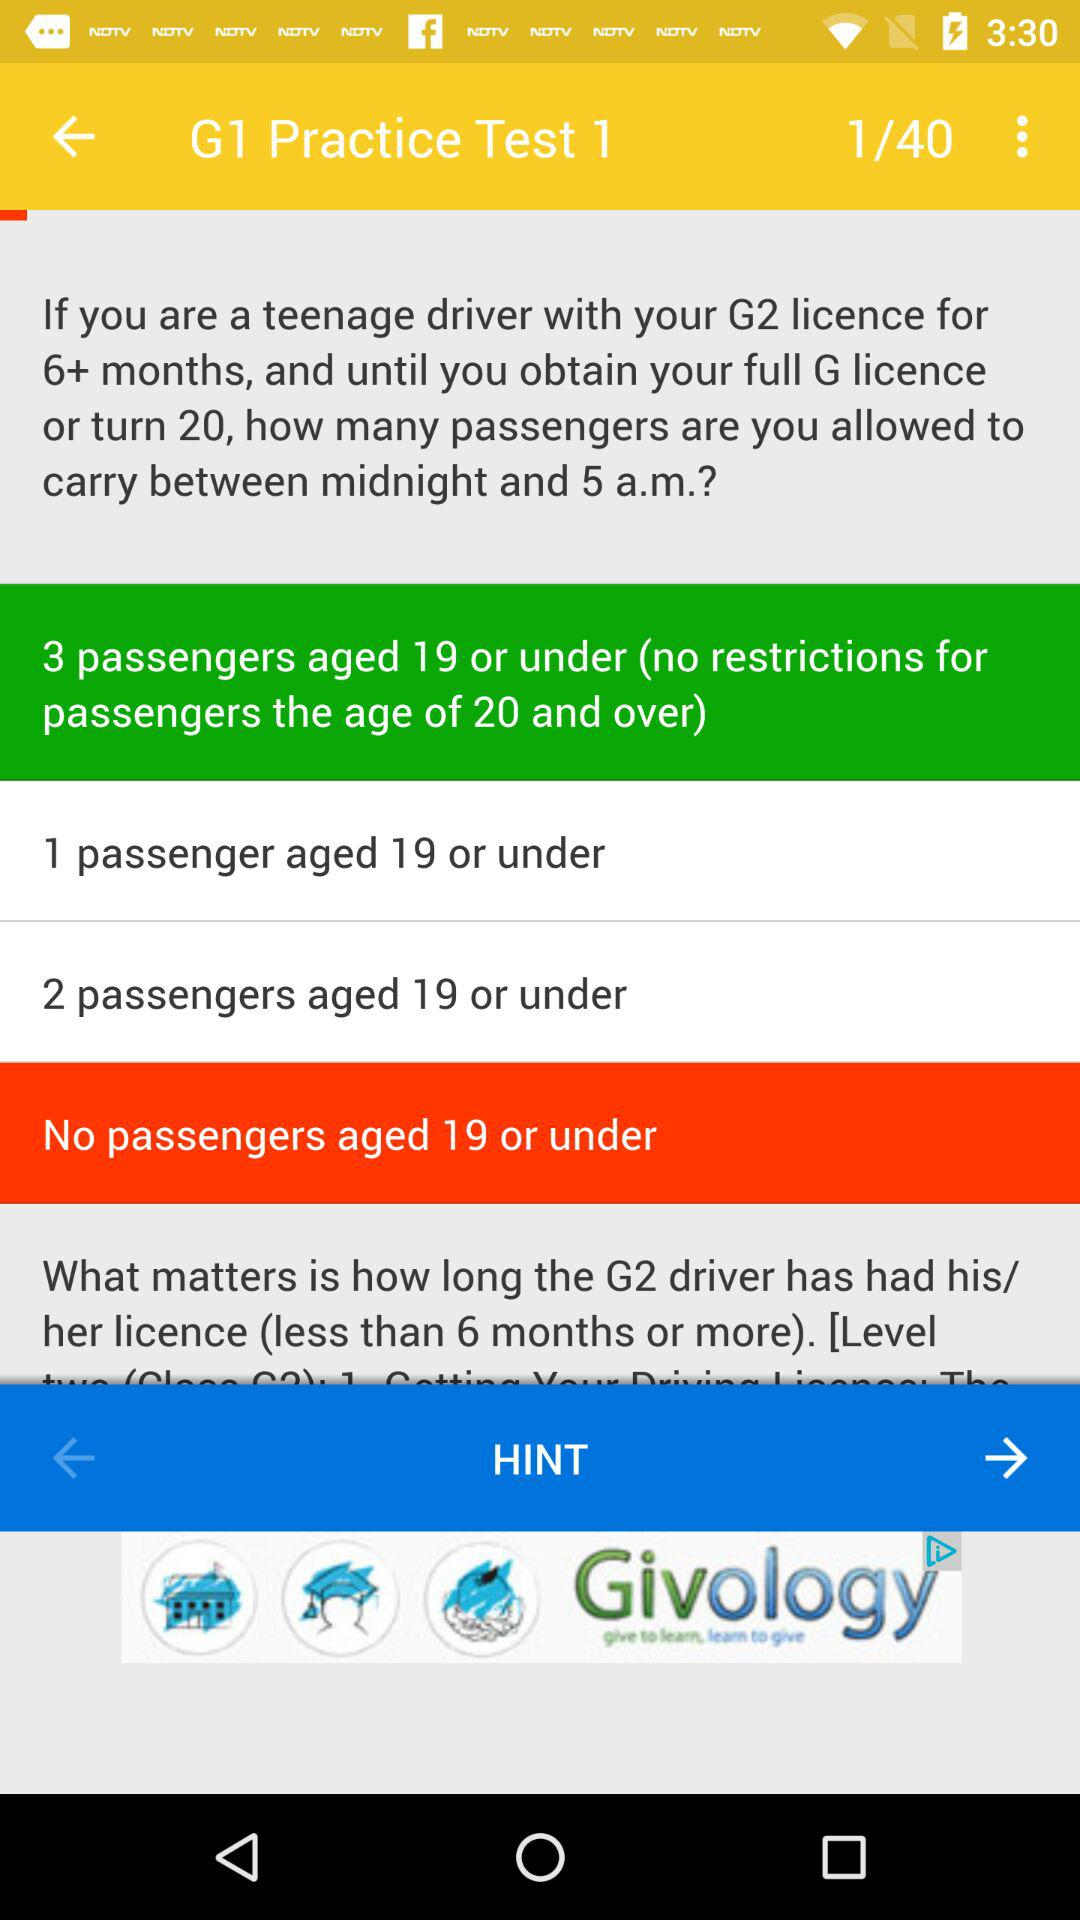How many passengers aged 19 or under can a G2 driver with their licence for 6+ months carry?
Answer the question using a single word or phrase. 3 